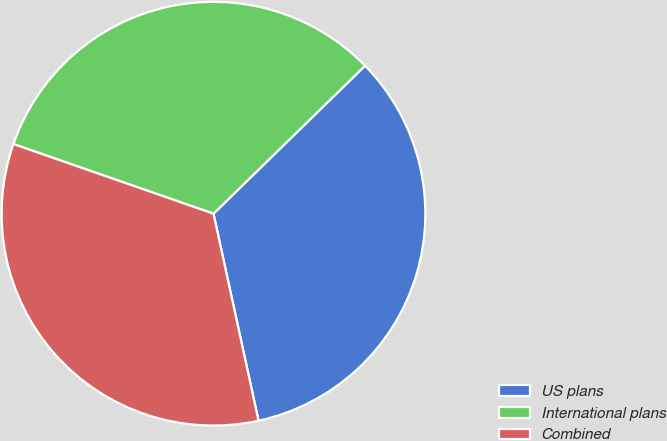Convert chart. <chart><loc_0><loc_0><loc_500><loc_500><pie_chart><fcel>US plans<fcel>International plans<fcel>Combined<nl><fcel>33.9%<fcel>32.36%<fcel>33.74%<nl></chart> 